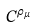<formula> <loc_0><loc_0><loc_500><loc_500>C ^ { \rho _ { \mu } }</formula> 